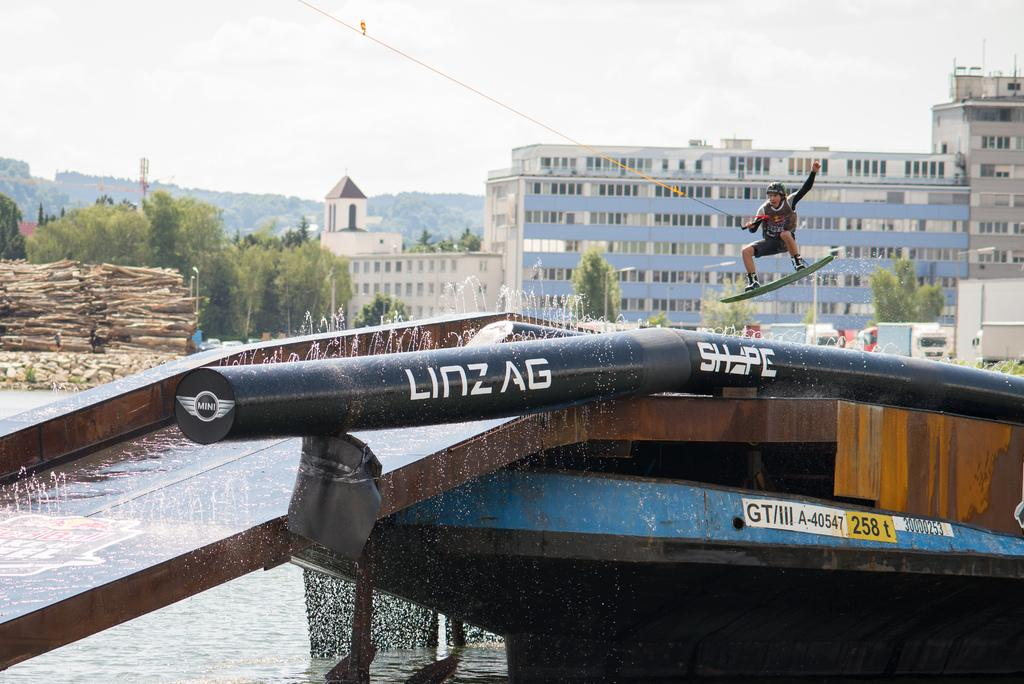Provide a one-sentence caption for the provided image. the word Linzag that is on the boat. 